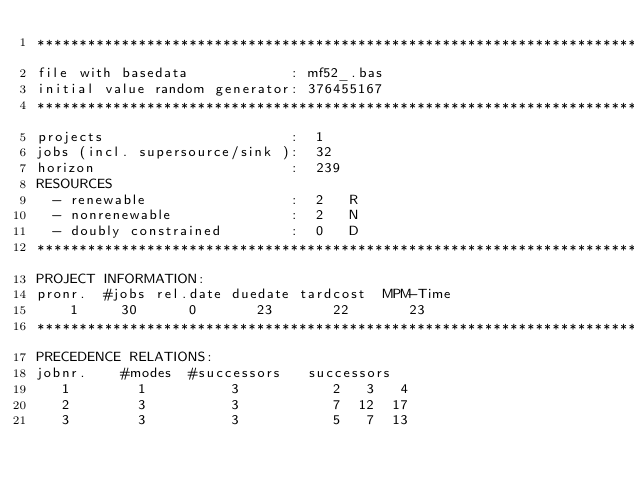<code> <loc_0><loc_0><loc_500><loc_500><_ObjectiveC_>************************************************************************
file with basedata            : mf52_.bas
initial value random generator: 376455167
************************************************************************
projects                      :  1
jobs (incl. supersource/sink ):  32
horizon                       :  239
RESOURCES
  - renewable                 :  2   R
  - nonrenewable              :  2   N
  - doubly constrained        :  0   D
************************************************************************
PROJECT INFORMATION:
pronr.  #jobs rel.date duedate tardcost  MPM-Time
    1     30      0       23       22       23
************************************************************************
PRECEDENCE RELATIONS:
jobnr.    #modes  #successors   successors
   1        1          3           2   3   4
   2        3          3           7  12  17
   3        3          3           5   7  13</code> 